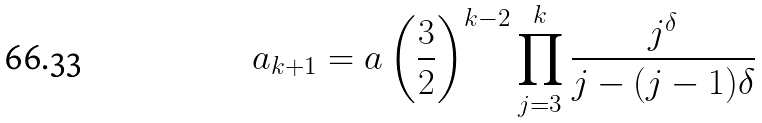Convert formula to latex. <formula><loc_0><loc_0><loc_500><loc_500>a _ { k + 1 } = a \left ( \frac { 3 } { 2 } \right ) ^ { k - 2 } \prod _ { j = 3 } ^ { k } \frac { j ^ { \delta } } { j - ( j - 1 ) \delta }</formula> 